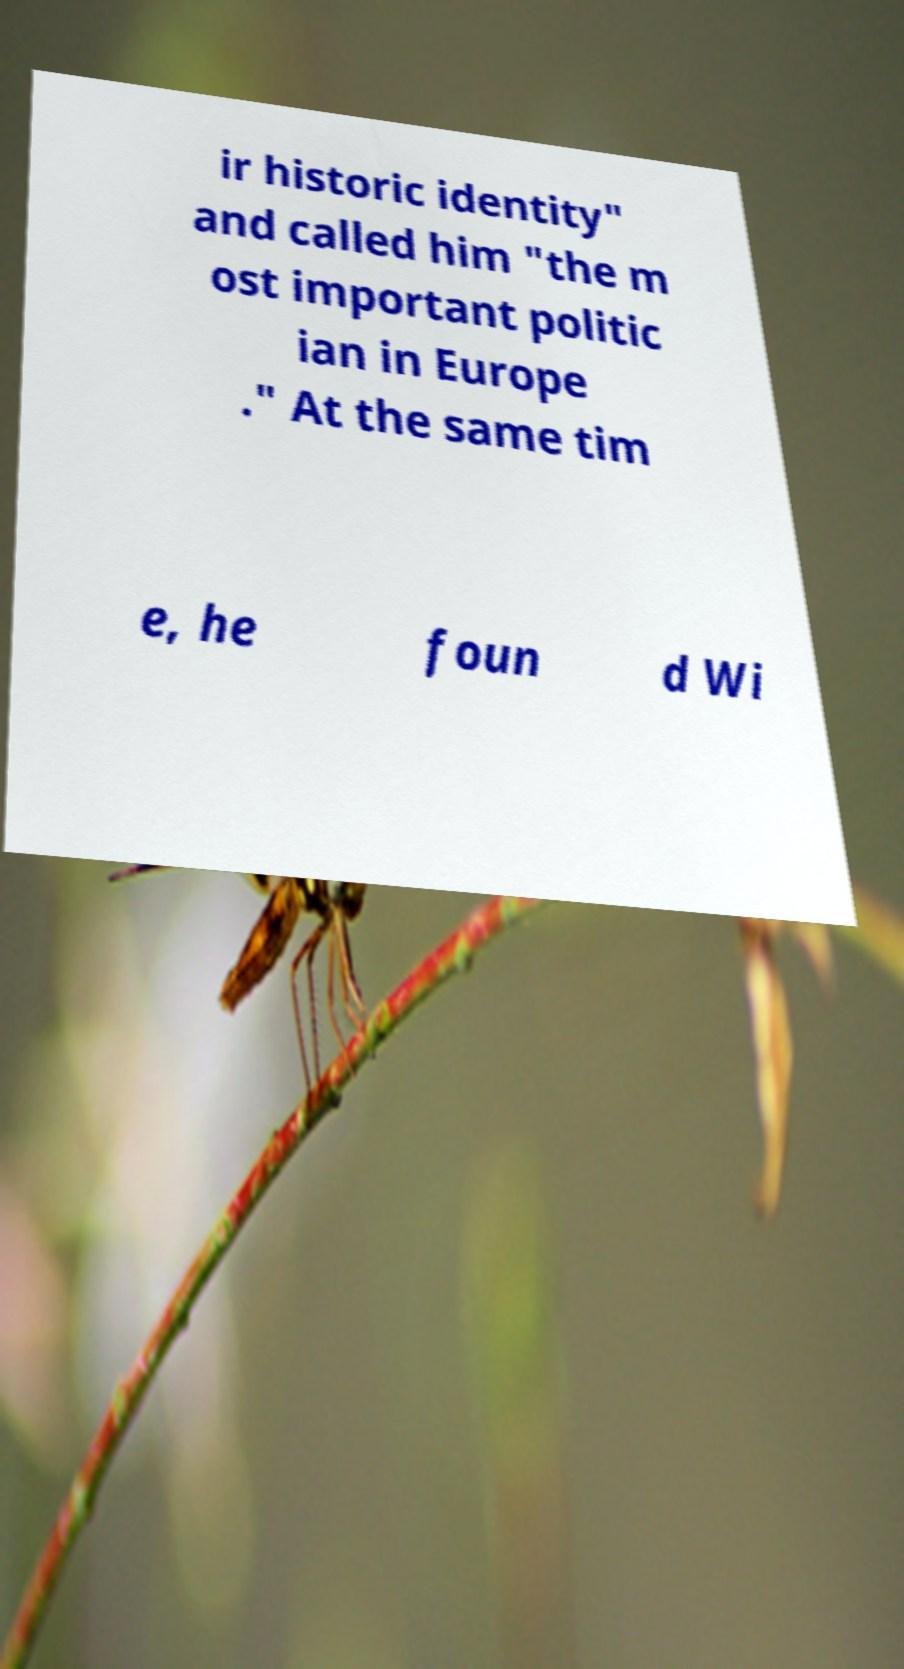There's text embedded in this image that I need extracted. Can you transcribe it verbatim? ir historic identity" and called him "the m ost important politic ian in Europe ." At the same tim e, he foun d Wi 